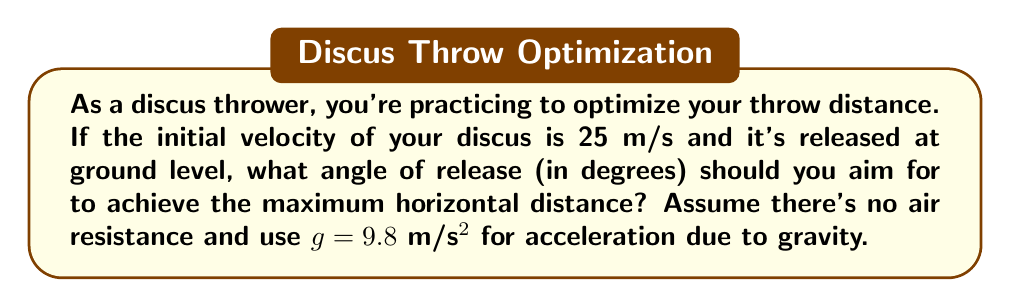Provide a solution to this math problem. Let's approach this step-by-step:

1) In projectile motion without air resistance, the maximum range is achieved when the angle of release is 45°. However, we can prove this mathematically.

2) The range (R) of a projectile launched from ground level is given by the equation:

   $$R = \frac{v_0^2 \sin(2\theta)}{g}$$

   Where $v_0$ is the initial velocity, $\theta$ is the angle of release, and $g$ is the acceleration due to gravity.

3) To find the maximum range, we need to find the value of $\theta$ that maximizes this function. We can do this by taking the derivative with respect to $\theta$ and setting it to zero:

   $$\frac{dR}{d\theta} = \frac{v_0^2 \cdot 2\cos(2\theta)}{g} = 0$$

4) This equation is satisfied when $\cos(2\theta) = 0$, which occurs when $2\theta = 90°$ or $\theta = 45°$.

5) We can confirm this is a maximum (not a minimum) by checking the second derivative or by observing the behavior of the function.

6) Therefore, the angle that maximizes the range is 45°, regardless of the initial velocity or the value of g.

This result is theoretically correct for all projectile motions in a vacuum. In practice, factors like air resistance and the aerodynamics of the discus might slightly alter the optimal angle, but 45° is a good starting point for training.
Answer: 45° 